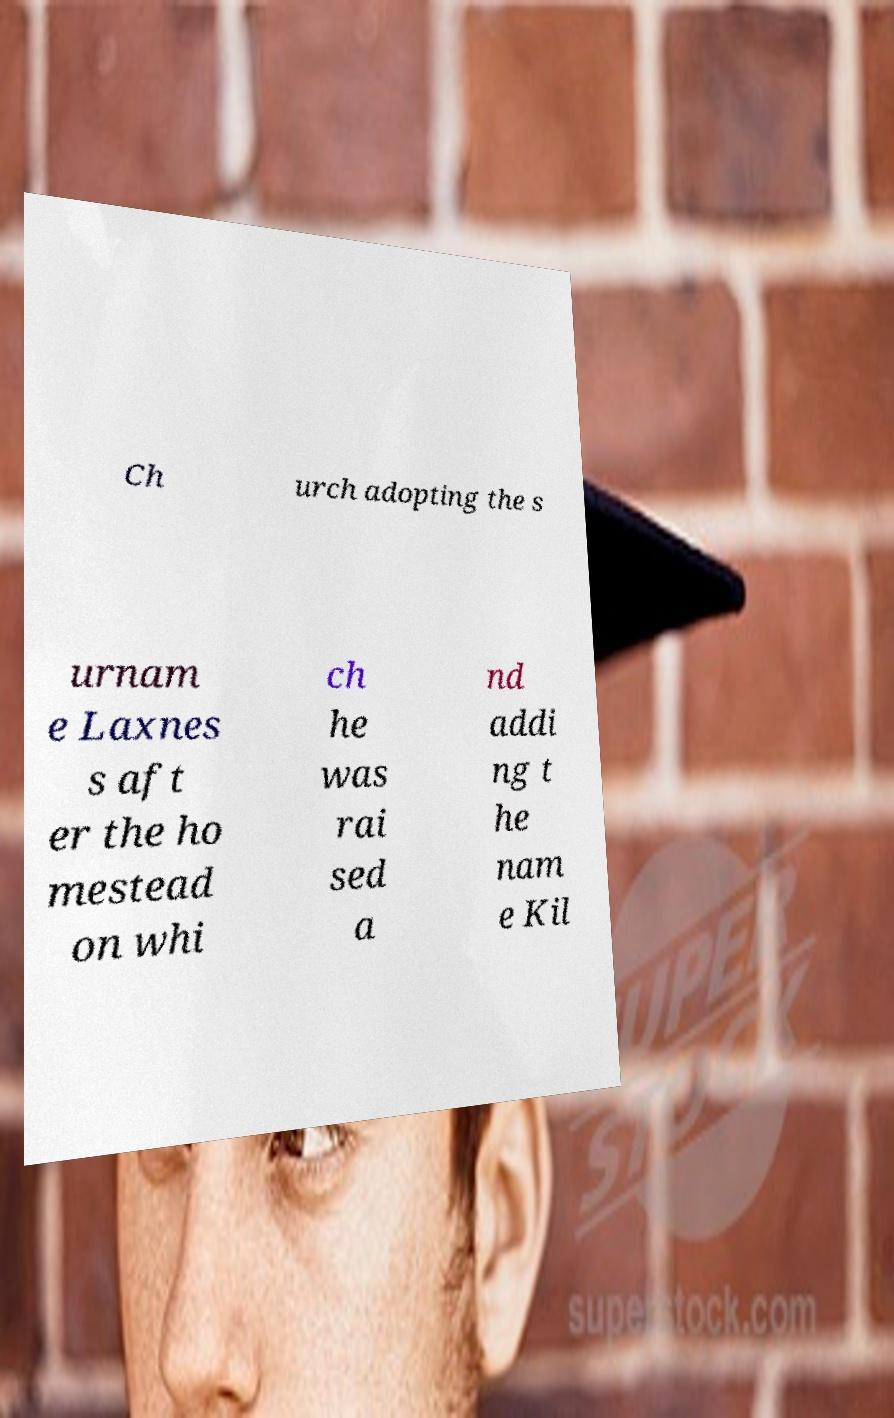Could you assist in decoding the text presented in this image and type it out clearly? Ch urch adopting the s urnam e Laxnes s aft er the ho mestead on whi ch he was rai sed a nd addi ng t he nam e Kil 